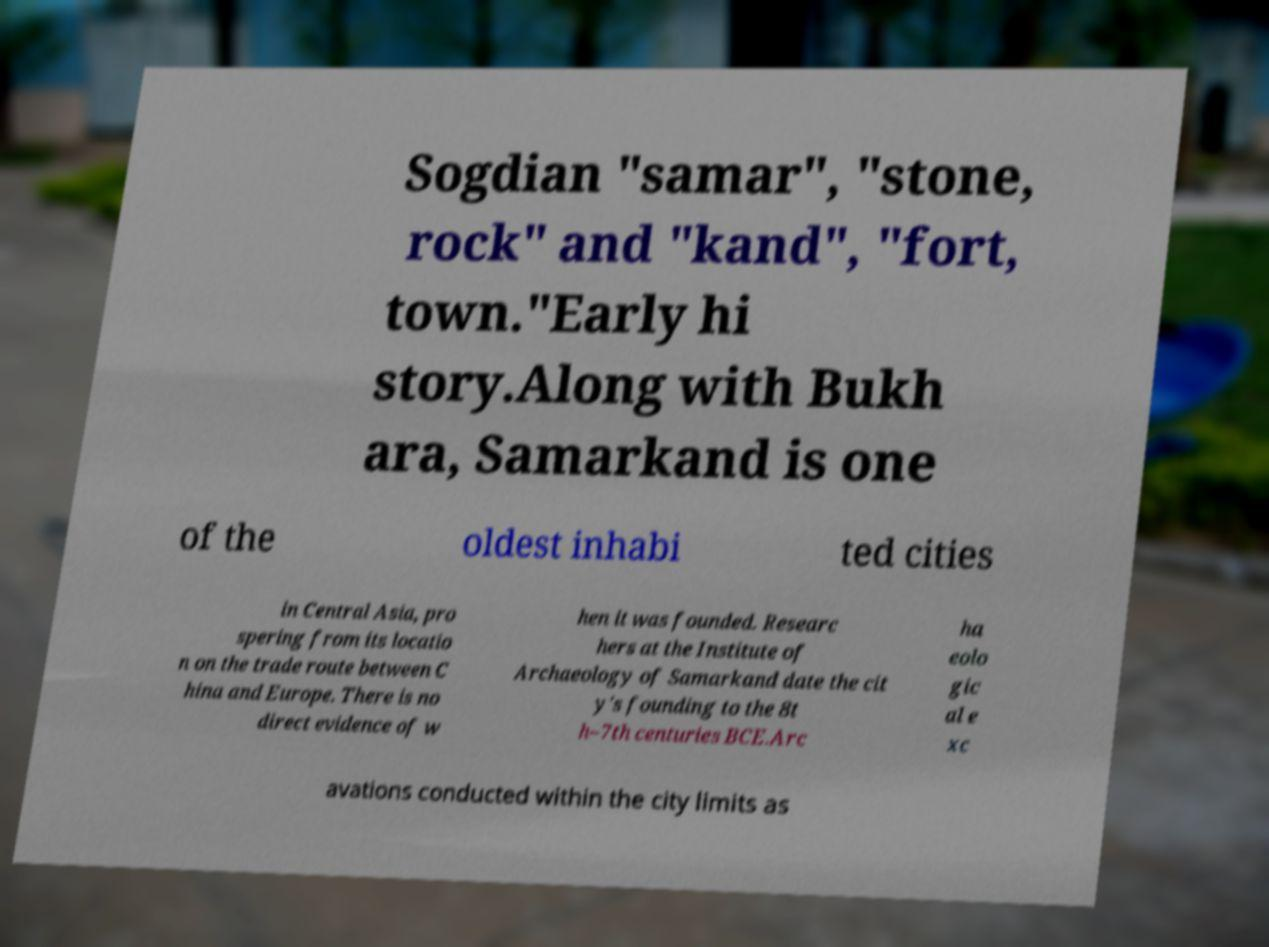Please read and relay the text visible in this image. What does it say? Sogdian "samar", "stone, rock" and "kand", "fort, town."Early hi story.Along with Bukh ara, Samarkand is one of the oldest inhabi ted cities in Central Asia, pro spering from its locatio n on the trade route between C hina and Europe. There is no direct evidence of w hen it was founded. Researc hers at the Institute of Archaeology of Samarkand date the cit y's founding to the 8t h–7th centuries BCE.Arc ha eolo gic al e xc avations conducted within the city limits as 